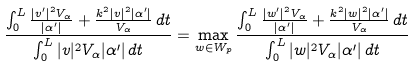Convert formula to latex. <formula><loc_0><loc_0><loc_500><loc_500>\frac { \int _ { 0 } ^ { L } \frac { | v ^ { \prime } | ^ { 2 } V _ { \alpha } } { | \alpha ^ { \prime } | } + \frac { k ^ { 2 } | v | ^ { 2 } | \alpha ^ { \prime } | } { V _ { \alpha } } \, d t } { \int _ { 0 } ^ { L } | v | ^ { 2 } V _ { \alpha } | \alpha ^ { \prime } | \, d t } = \max _ { w \in W _ { p } } \frac { \int _ { 0 } ^ { L } \frac { | w ^ { \prime } | ^ { 2 } V _ { \alpha } } { | \alpha ^ { \prime } | } + \frac { k ^ { 2 } | w | ^ { 2 } | \alpha ^ { \prime } | } { V _ { \alpha } } \, d t } { \int _ { 0 } ^ { L } | w | ^ { 2 } V _ { \alpha } | \alpha ^ { \prime } | \, d t }</formula> 